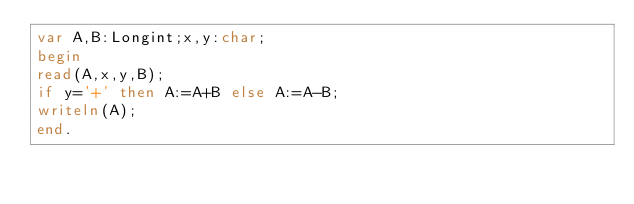Convert code to text. <code><loc_0><loc_0><loc_500><loc_500><_Pascal_>var A,B:Longint;x,y:char;
begin
read(A,x,y,B);
if y='+' then A:=A+B else A:=A-B;
writeln(A);
end.</code> 